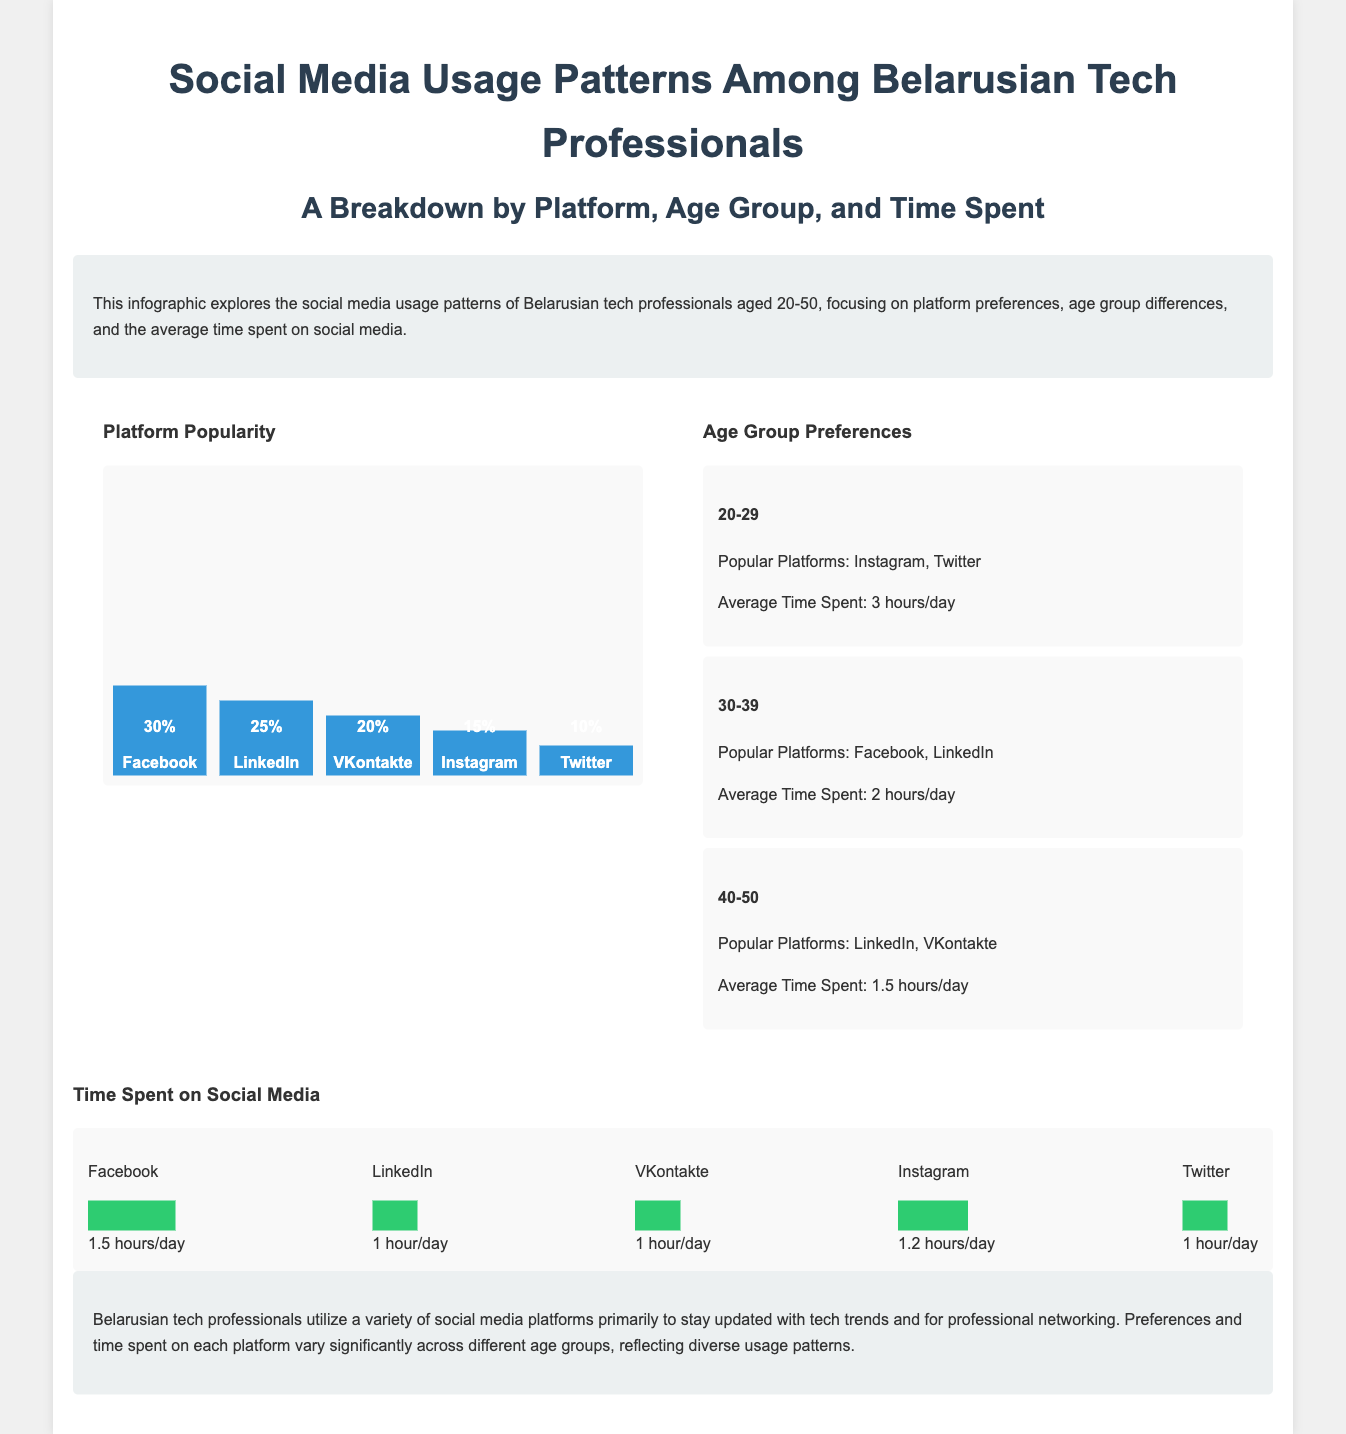What is the most popular social media platform among Belarusian tech professionals? The document indicates that Facebook is the most popular social media platform, with a popularity of 30%.
Answer: Facebook What percentage of tech professionals uses LinkedIn? LinkedIn is used by 25% of Belarusian tech professionals, as stated in the platform popularity section.
Answer: 25% What is the average time spent on Instagram by the 20-29 age group? The average time spent by the 20-29 age group is mentioned to be 3 hours/day, with Instagram being one of their popular platforms.
Answer: 3 hours/day Which age group prefers VKontakte the most? The 40-50 age group is stated to prefer VKontakte, as outlined in the age group preferences.
Answer: 40-50 What is the average time spent on LinkedIn daily? The document specifies that the average time spent on LinkedIn is 1 hour/day.
Answer: 1 hour/day Which two platforms are popular among the 30-39 age group? The 30-39 age group is shown to favor Facebook and LinkedIn, based on the document’s insights.
Answer: Facebook, LinkedIn How many hours per day does the 40-50 age group spend on social media? The average time spent on social media by the 40-50 age group is stated to be 1.5 hours/day.
Answer: 1.5 hours/day What background color is used for the introduction section of the infographic? The introduction section is highlighted with a background color of #ecf0f1, providing a soft contrast.
Answer: #ecf0f1 What is the primary reason for social media usage among Belarusian tech professionals according to the document? The document concludes that the primary reason for their social media usage is to stay updated with tech trends and for professional networking.
Answer: Stay updated with tech trends and professional networking 